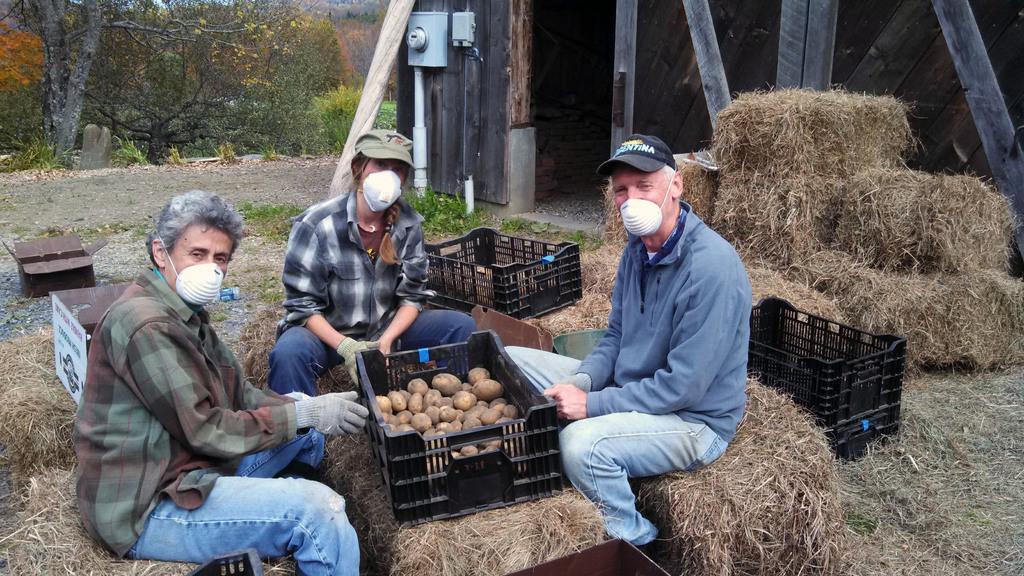In one or two sentences, can you explain what this image depicts? In the image few people are sitting and there are some baskets. Behind the basket there is grass and shed and trees. 